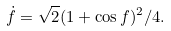Convert formula to latex. <formula><loc_0><loc_0><loc_500><loc_500>\dot { f } = \sqrt { 2 } ( 1 + \cos f ) ^ { 2 } / 4 .</formula> 